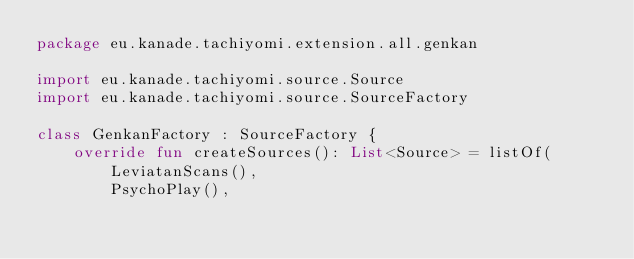Convert code to text. <code><loc_0><loc_0><loc_500><loc_500><_Kotlin_>package eu.kanade.tachiyomi.extension.all.genkan

import eu.kanade.tachiyomi.source.Source
import eu.kanade.tachiyomi.source.SourceFactory

class GenkanFactory : SourceFactory {
    override fun createSources(): List<Source> = listOf(
        LeviatanScans(),
        PsychoPlay(),</code> 